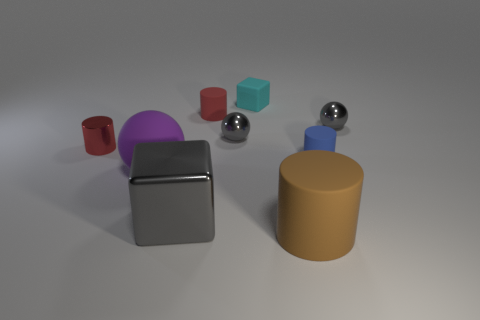Subtract all balls. How many objects are left? 6 Subtract all purple objects. Subtract all small gray things. How many objects are left? 6 Add 8 gray shiny blocks. How many gray shiny blocks are left? 9 Add 4 tiny objects. How many tiny objects exist? 10 Subtract 0 green cylinders. How many objects are left? 9 